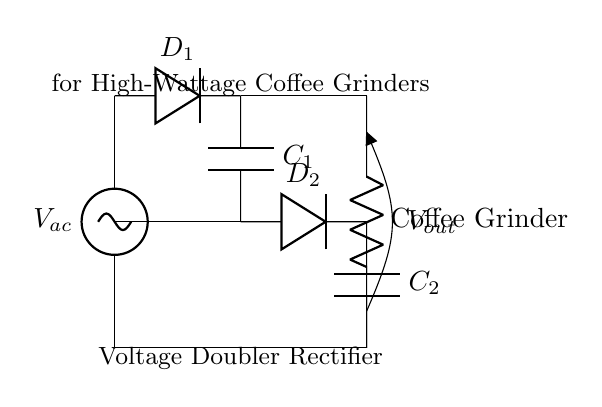What is the type of circuit shown? The circuit is a voltage doubler rectifier. It can be identified by the arrangement of diodes and capacitors that is specifically designed to increase the output voltage effectively.
Answer: Voltage doubler rectifier How many diodes are used in the circuit? The circuit diagram illustrates the use of two diodes, which are marked as D1 and D2. Each diode conducts during different phases of the alternating current, helping to rectify the input voltage.
Answer: Two What components are used for voltage storage in the circuit? The components used for voltage storage are capacitors C1 and C2. Capacitors are utilized in rectifier circuits to smooth out the output voltage and deliver stable power.
Answer: Capacitors Which component is directly connected to the coffee grinder? The component directly connected to the coffee grinder is the resistor marked as "Coffee Grinder." This load receives the rectified voltage output from the circuit.
Answer: Coffee Grinder What does the output voltage represent in this circuit? The output voltage, denoted as Vout, represents the voltage available for powering the load, in this case, the coffee grinder. It is doubled due to the design of the voltage doubler rectifier.
Answer: Vout What is the function of the second capacitor in the circuit? The function of C2 in the circuit is to store the additional charge, which helps to maintain the output voltage level higher than the input voltage over time, effectively doubling the output voltage in conjunction with C1.
Answer: Store charge How does the configuration of diodes affect output voltage? The diodes are arranged in a manner that allows current to flow into the capacitors during the positive half-cycles of the AC input. This configuration enables the voltage to accumulate, resulting in a higher output voltage.
Answer: Allows voltage accumulation 